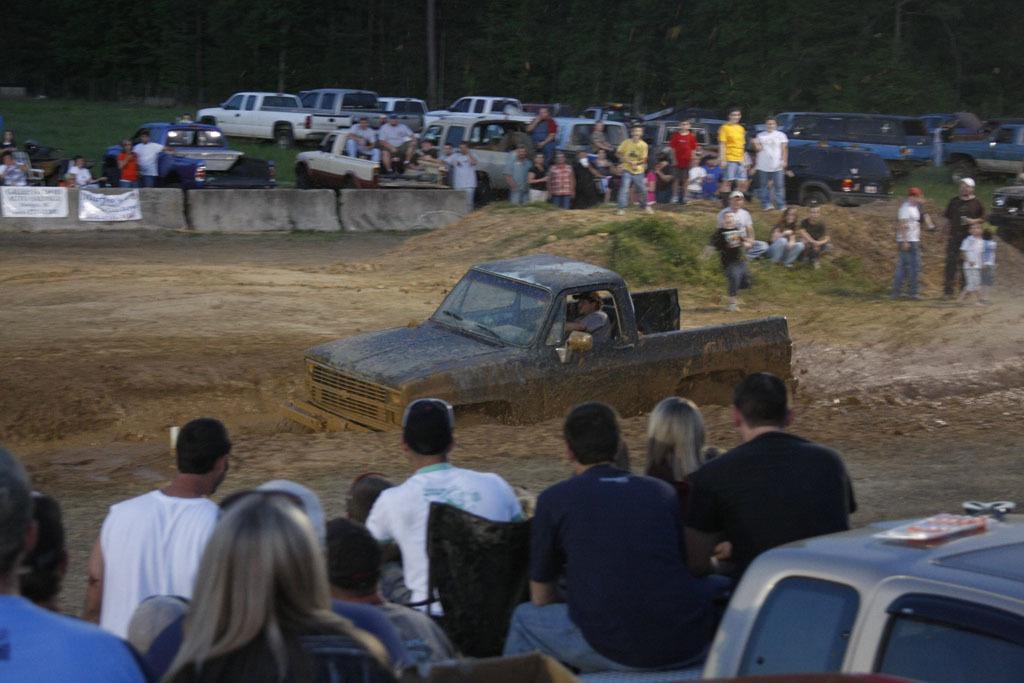How would you summarize this image in a sentence or two? In this picture I can observe black color vehicle in the middle of the picture. It is moving in the mud. In the background I can observe some vehicles parked on the land. In this picture I can observe some people. In the background there are trees. 